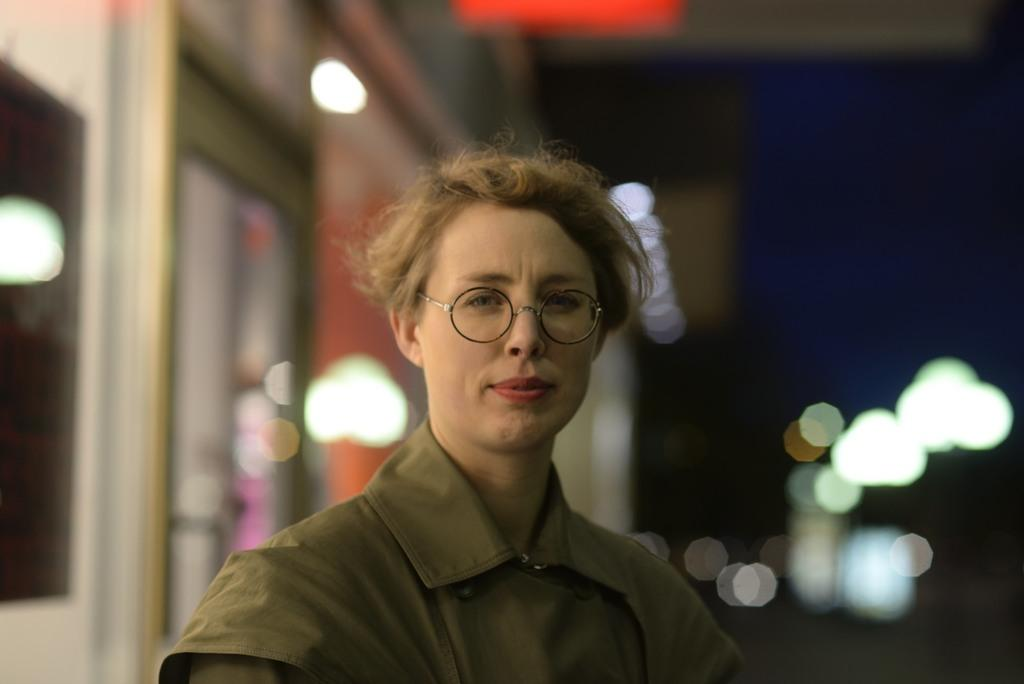Who is present in the image? There is a woman in the image. What is the woman wearing on her face? The woman is wearing spectacles. What can be seen in the left corner of the image? There is a store in the left corner of the image. What is present in the right corner of the image? There are lights and other objects in the right corner of the image. What type of lip can be seen on the woman in the image? There is no lip visible on the woman in the image; she is wearing spectacles. What kind of cup is being used by the woman in the image? There is no cup present in the image. 